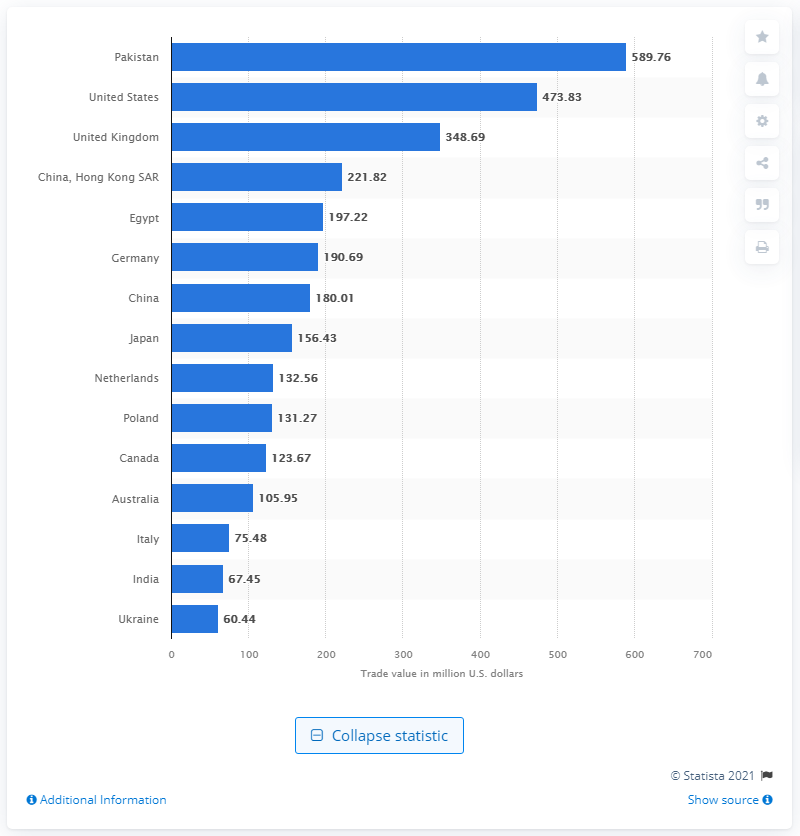Which country imported the second-highest amount of tea in 2020? Based on the displayed bar chart, Pakistan was the second-largest importer of tea in 2020, with a recorded value of 473.83 million U.S. dollars. What can you tell me about the top three tea importers from this data? The bar chart reveals that the top three tea importers in 2020 were the United States, Pakistan, and the United Kingdom, with the U.S. leading at around 590 million U.S. dollars, Pakistan following at approximately 474 million U.S. dollars, and the UK not far behind at roughly 349 million U.S. dollars. 